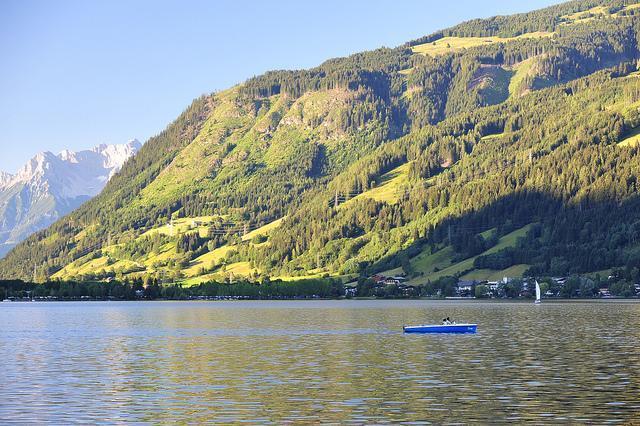How many donuts are in this picture?
Give a very brief answer. 0. 